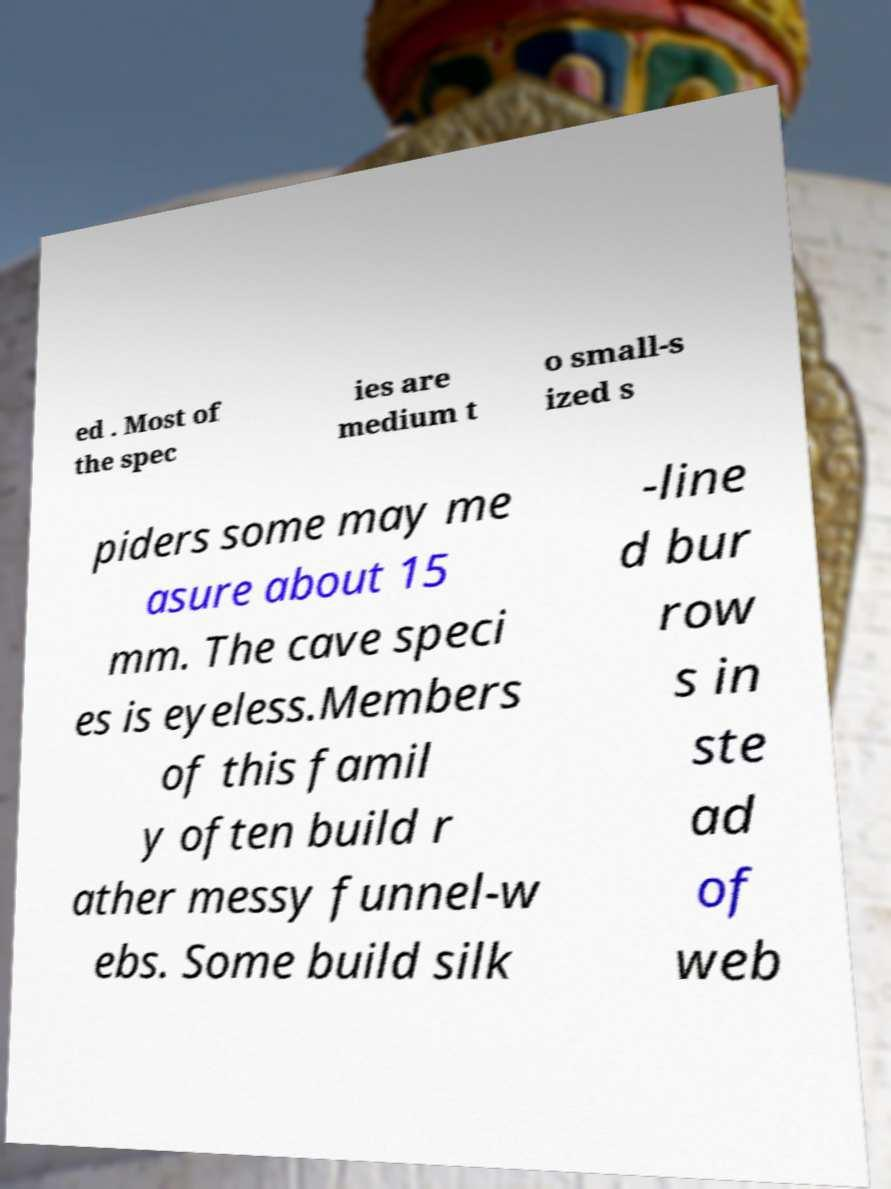Could you assist in decoding the text presented in this image and type it out clearly? ed . Most of the spec ies are medium t o small-s ized s piders some may me asure about 15 mm. The cave speci es is eyeless.Members of this famil y often build r ather messy funnel-w ebs. Some build silk -line d bur row s in ste ad of web 